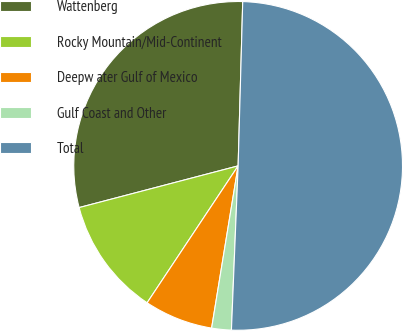Convert chart to OTSL. <chart><loc_0><loc_0><loc_500><loc_500><pie_chart><fcel>Wattenberg<fcel>Rocky Mountain/Mid-Continent<fcel>Deepw ater Gulf of Mexico<fcel>Gulf Coast and Other<fcel>Total<nl><fcel>29.53%<fcel>11.58%<fcel>6.76%<fcel>1.93%<fcel>50.21%<nl></chart> 